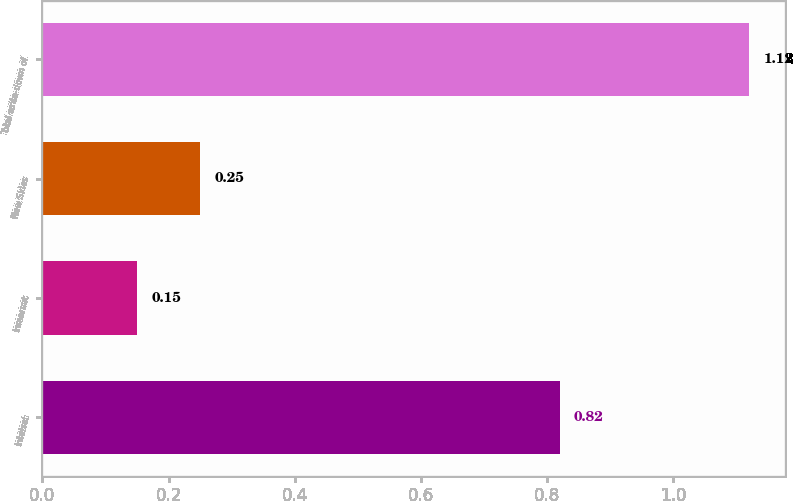<chart> <loc_0><loc_0><loc_500><loc_500><bar_chart><fcel>Intelsat<fcel>Inmarsat<fcel>New Skies<fcel>Total write-down of<nl><fcel>0.82<fcel>0.15<fcel>0.25<fcel>1.12<nl></chart> 